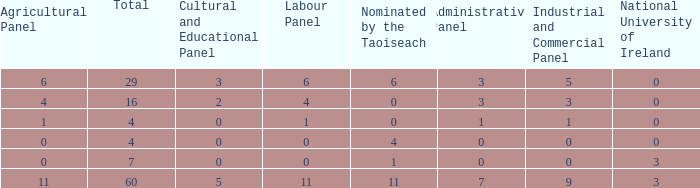What is the average nominated of the composition nominated by Taioseach with an Industrial and Commercial panel less than 9, an administrative panel greater than 0, a cultural and educational panel greater than 2, and a total less than 29? None. 